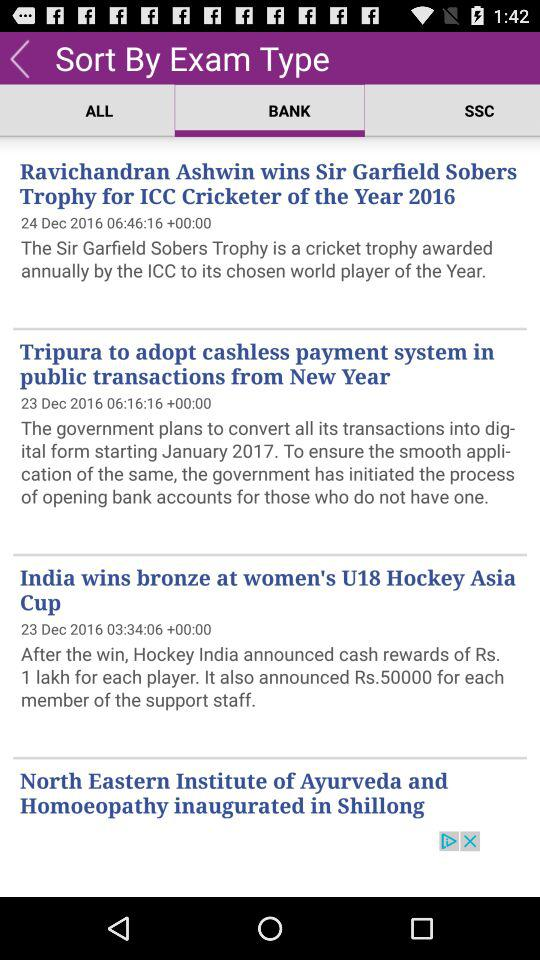What is the cash reward announced by Hockey India for each player? The cash reward is Rs 1 lakh. 